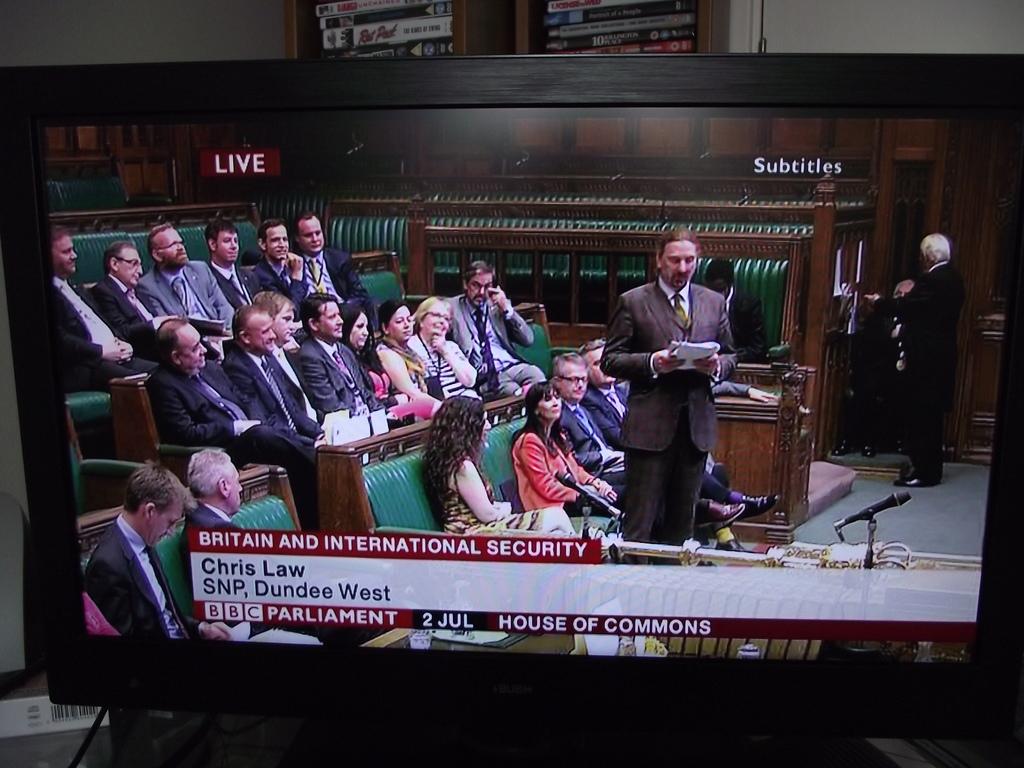Who is speaking?
Give a very brief answer. Chris law. What date is displayed?
Offer a very short reply. 2 jul. 